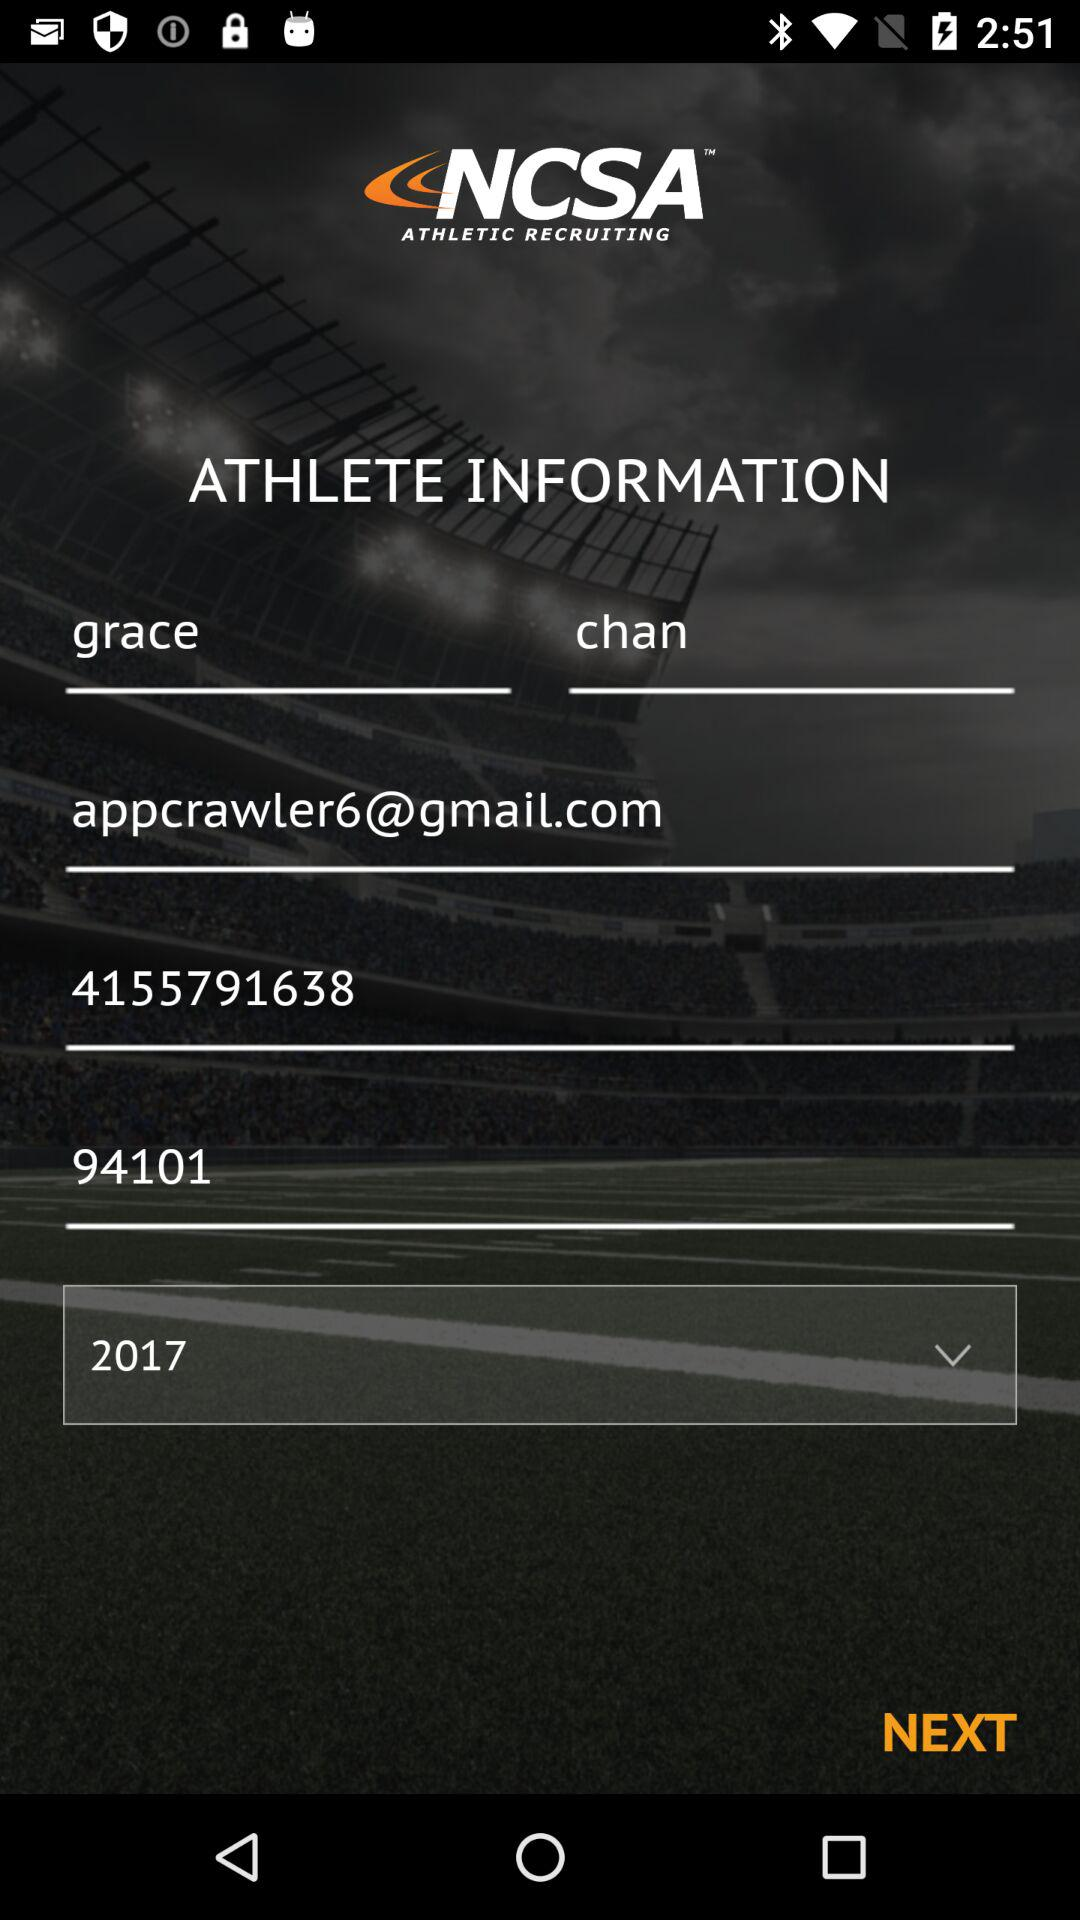What is the user's first name? The user's first name is Grace. 